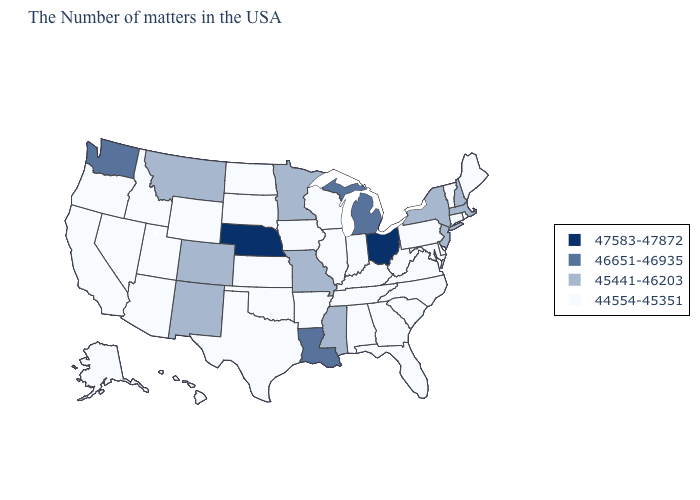Name the states that have a value in the range 46651-46935?
Write a very short answer. Michigan, Louisiana, Washington. How many symbols are there in the legend?
Keep it brief. 4. What is the value of Montana?
Concise answer only. 45441-46203. Name the states that have a value in the range 47583-47872?
Quick response, please. Ohio, Nebraska. What is the lowest value in the Northeast?
Be succinct. 44554-45351. Does the map have missing data?
Be succinct. No. Which states have the lowest value in the USA?
Write a very short answer. Maine, Rhode Island, Vermont, Connecticut, Delaware, Maryland, Pennsylvania, Virginia, North Carolina, South Carolina, West Virginia, Florida, Georgia, Kentucky, Indiana, Alabama, Tennessee, Wisconsin, Illinois, Arkansas, Iowa, Kansas, Oklahoma, Texas, South Dakota, North Dakota, Wyoming, Utah, Arizona, Idaho, Nevada, California, Oregon, Alaska, Hawaii. What is the value of Michigan?
Write a very short answer. 46651-46935. Among the states that border Pennsylvania , which have the highest value?
Be succinct. Ohio. Does the map have missing data?
Answer briefly. No. What is the lowest value in the South?
Write a very short answer. 44554-45351. What is the value of North Carolina?
Concise answer only. 44554-45351. Among the states that border Oklahoma , which have the highest value?
Be succinct. Missouri, Colorado, New Mexico. Name the states that have a value in the range 46651-46935?
Concise answer only. Michigan, Louisiana, Washington. 